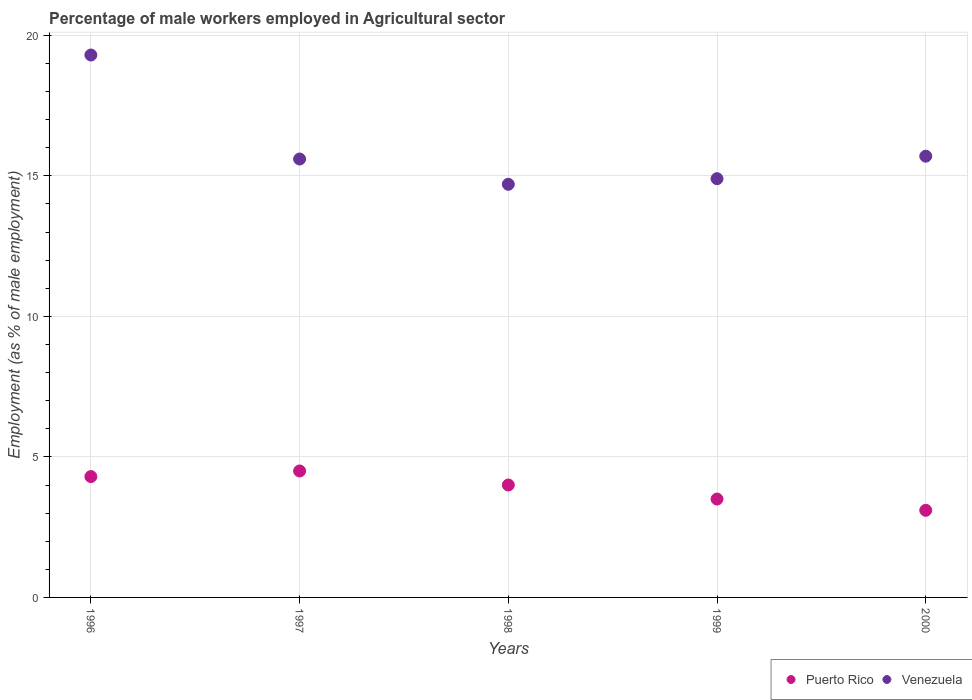Is the number of dotlines equal to the number of legend labels?
Your answer should be compact. Yes. Across all years, what is the maximum percentage of male workers employed in Agricultural sector in Venezuela?
Your answer should be compact. 19.3. Across all years, what is the minimum percentage of male workers employed in Agricultural sector in Venezuela?
Keep it short and to the point. 14.7. What is the total percentage of male workers employed in Agricultural sector in Venezuela in the graph?
Your response must be concise. 80.2. What is the difference between the percentage of male workers employed in Agricultural sector in Venezuela in 1996 and that in 1999?
Provide a short and direct response. 4.4. What is the difference between the percentage of male workers employed in Agricultural sector in Venezuela in 1999 and the percentage of male workers employed in Agricultural sector in Puerto Rico in 2000?
Make the answer very short. 11.8. What is the average percentage of male workers employed in Agricultural sector in Puerto Rico per year?
Ensure brevity in your answer.  3.88. In the year 1998, what is the difference between the percentage of male workers employed in Agricultural sector in Venezuela and percentage of male workers employed in Agricultural sector in Puerto Rico?
Offer a terse response. 10.7. In how many years, is the percentage of male workers employed in Agricultural sector in Venezuela greater than 17 %?
Make the answer very short. 1. What is the ratio of the percentage of male workers employed in Agricultural sector in Venezuela in 1998 to that in 1999?
Ensure brevity in your answer.  0.99. What is the difference between the highest and the second highest percentage of male workers employed in Agricultural sector in Puerto Rico?
Keep it short and to the point. 0.2. What is the difference between the highest and the lowest percentage of male workers employed in Agricultural sector in Venezuela?
Offer a very short reply. 4.6. Is the sum of the percentage of male workers employed in Agricultural sector in Venezuela in 1997 and 1998 greater than the maximum percentage of male workers employed in Agricultural sector in Puerto Rico across all years?
Offer a very short reply. Yes. Does the percentage of male workers employed in Agricultural sector in Venezuela monotonically increase over the years?
Offer a terse response. No. How many dotlines are there?
Your answer should be very brief. 2. How many years are there in the graph?
Provide a succinct answer. 5. What is the difference between two consecutive major ticks on the Y-axis?
Ensure brevity in your answer.  5. Does the graph contain any zero values?
Your answer should be compact. No. Where does the legend appear in the graph?
Offer a very short reply. Bottom right. How many legend labels are there?
Your answer should be very brief. 2. What is the title of the graph?
Your response must be concise. Percentage of male workers employed in Agricultural sector. Does "Congo (Republic)" appear as one of the legend labels in the graph?
Offer a terse response. No. What is the label or title of the X-axis?
Provide a succinct answer. Years. What is the label or title of the Y-axis?
Your answer should be very brief. Employment (as % of male employment). What is the Employment (as % of male employment) of Puerto Rico in 1996?
Offer a very short reply. 4.3. What is the Employment (as % of male employment) of Venezuela in 1996?
Your answer should be very brief. 19.3. What is the Employment (as % of male employment) of Venezuela in 1997?
Offer a terse response. 15.6. What is the Employment (as % of male employment) in Puerto Rico in 1998?
Make the answer very short. 4. What is the Employment (as % of male employment) in Venezuela in 1998?
Make the answer very short. 14.7. What is the Employment (as % of male employment) in Venezuela in 1999?
Provide a succinct answer. 14.9. What is the Employment (as % of male employment) in Puerto Rico in 2000?
Ensure brevity in your answer.  3.1. What is the Employment (as % of male employment) of Venezuela in 2000?
Your answer should be very brief. 15.7. Across all years, what is the maximum Employment (as % of male employment) of Puerto Rico?
Provide a short and direct response. 4.5. Across all years, what is the maximum Employment (as % of male employment) in Venezuela?
Make the answer very short. 19.3. Across all years, what is the minimum Employment (as % of male employment) of Puerto Rico?
Offer a terse response. 3.1. Across all years, what is the minimum Employment (as % of male employment) of Venezuela?
Your response must be concise. 14.7. What is the total Employment (as % of male employment) of Venezuela in the graph?
Your answer should be very brief. 80.2. What is the difference between the Employment (as % of male employment) of Puerto Rico in 1996 and that in 2000?
Provide a short and direct response. 1.2. What is the difference between the Employment (as % of male employment) of Venezuela in 1996 and that in 2000?
Your answer should be very brief. 3.6. What is the difference between the Employment (as % of male employment) of Puerto Rico in 1997 and that in 1998?
Your answer should be compact. 0.5. What is the difference between the Employment (as % of male employment) of Puerto Rico in 1997 and that in 2000?
Provide a succinct answer. 1.4. What is the difference between the Employment (as % of male employment) of Venezuela in 1997 and that in 2000?
Provide a short and direct response. -0.1. What is the difference between the Employment (as % of male employment) of Puerto Rico in 1998 and that in 1999?
Make the answer very short. 0.5. What is the difference between the Employment (as % of male employment) of Puerto Rico in 1998 and that in 2000?
Offer a terse response. 0.9. What is the difference between the Employment (as % of male employment) in Venezuela in 1998 and that in 2000?
Offer a very short reply. -1. What is the difference between the Employment (as % of male employment) of Puerto Rico in 1999 and that in 2000?
Provide a short and direct response. 0.4. What is the difference between the Employment (as % of male employment) in Venezuela in 1999 and that in 2000?
Ensure brevity in your answer.  -0.8. What is the difference between the Employment (as % of male employment) of Puerto Rico in 1996 and the Employment (as % of male employment) of Venezuela in 1997?
Your answer should be compact. -11.3. What is the difference between the Employment (as % of male employment) in Puerto Rico in 1996 and the Employment (as % of male employment) in Venezuela in 1999?
Keep it short and to the point. -10.6. What is the difference between the Employment (as % of male employment) of Puerto Rico in 1996 and the Employment (as % of male employment) of Venezuela in 2000?
Provide a succinct answer. -11.4. What is the difference between the Employment (as % of male employment) of Puerto Rico in 1997 and the Employment (as % of male employment) of Venezuela in 1998?
Offer a very short reply. -10.2. What is the difference between the Employment (as % of male employment) in Puerto Rico in 1997 and the Employment (as % of male employment) in Venezuela in 1999?
Ensure brevity in your answer.  -10.4. What is the difference between the Employment (as % of male employment) in Puerto Rico in 1997 and the Employment (as % of male employment) in Venezuela in 2000?
Offer a terse response. -11.2. What is the difference between the Employment (as % of male employment) in Puerto Rico in 1998 and the Employment (as % of male employment) in Venezuela in 1999?
Make the answer very short. -10.9. What is the difference between the Employment (as % of male employment) of Puerto Rico in 1998 and the Employment (as % of male employment) of Venezuela in 2000?
Offer a terse response. -11.7. What is the difference between the Employment (as % of male employment) of Puerto Rico in 1999 and the Employment (as % of male employment) of Venezuela in 2000?
Provide a succinct answer. -12.2. What is the average Employment (as % of male employment) in Puerto Rico per year?
Make the answer very short. 3.88. What is the average Employment (as % of male employment) of Venezuela per year?
Provide a short and direct response. 16.04. In the year 1998, what is the difference between the Employment (as % of male employment) in Puerto Rico and Employment (as % of male employment) in Venezuela?
Ensure brevity in your answer.  -10.7. In the year 1999, what is the difference between the Employment (as % of male employment) in Puerto Rico and Employment (as % of male employment) in Venezuela?
Give a very brief answer. -11.4. In the year 2000, what is the difference between the Employment (as % of male employment) of Puerto Rico and Employment (as % of male employment) of Venezuela?
Your answer should be compact. -12.6. What is the ratio of the Employment (as % of male employment) in Puerto Rico in 1996 to that in 1997?
Your answer should be compact. 0.96. What is the ratio of the Employment (as % of male employment) of Venezuela in 1996 to that in 1997?
Offer a terse response. 1.24. What is the ratio of the Employment (as % of male employment) of Puerto Rico in 1996 to that in 1998?
Offer a terse response. 1.07. What is the ratio of the Employment (as % of male employment) of Venezuela in 1996 to that in 1998?
Ensure brevity in your answer.  1.31. What is the ratio of the Employment (as % of male employment) of Puerto Rico in 1996 to that in 1999?
Ensure brevity in your answer.  1.23. What is the ratio of the Employment (as % of male employment) of Venezuela in 1996 to that in 1999?
Make the answer very short. 1.3. What is the ratio of the Employment (as % of male employment) of Puerto Rico in 1996 to that in 2000?
Your answer should be compact. 1.39. What is the ratio of the Employment (as % of male employment) in Venezuela in 1996 to that in 2000?
Provide a succinct answer. 1.23. What is the ratio of the Employment (as % of male employment) in Puerto Rico in 1997 to that in 1998?
Make the answer very short. 1.12. What is the ratio of the Employment (as % of male employment) of Venezuela in 1997 to that in 1998?
Your answer should be compact. 1.06. What is the ratio of the Employment (as % of male employment) of Venezuela in 1997 to that in 1999?
Ensure brevity in your answer.  1.05. What is the ratio of the Employment (as % of male employment) in Puerto Rico in 1997 to that in 2000?
Offer a very short reply. 1.45. What is the ratio of the Employment (as % of male employment) in Venezuela in 1997 to that in 2000?
Offer a terse response. 0.99. What is the ratio of the Employment (as % of male employment) of Venezuela in 1998 to that in 1999?
Your answer should be compact. 0.99. What is the ratio of the Employment (as % of male employment) of Puerto Rico in 1998 to that in 2000?
Your response must be concise. 1.29. What is the ratio of the Employment (as % of male employment) of Venezuela in 1998 to that in 2000?
Ensure brevity in your answer.  0.94. What is the ratio of the Employment (as % of male employment) in Puerto Rico in 1999 to that in 2000?
Keep it short and to the point. 1.13. What is the ratio of the Employment (as % of male employment) in Venezuela in 1999 to that in 2000?
Your answer should be very brief. 0.95. What is the difference between the highest and the second highest Employment (as % of male employment) in Venezuela?
Offer a very short reply. 3.6. 